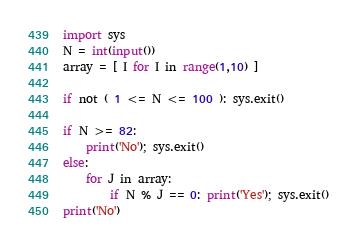<code> <loc_0><loc_0><loc_500><loc_500><_Python_>import sys
N = int(input())
array = [ I for I in range(1,10) ]

if not ( 1 <= N <= 100 ): sys.exit()

if N >= 82:
    print('No'); sys.exit()
else:
    for J in array:
        if N % J == 0: print('Yes'); sys.exit()
print('No')</code> 